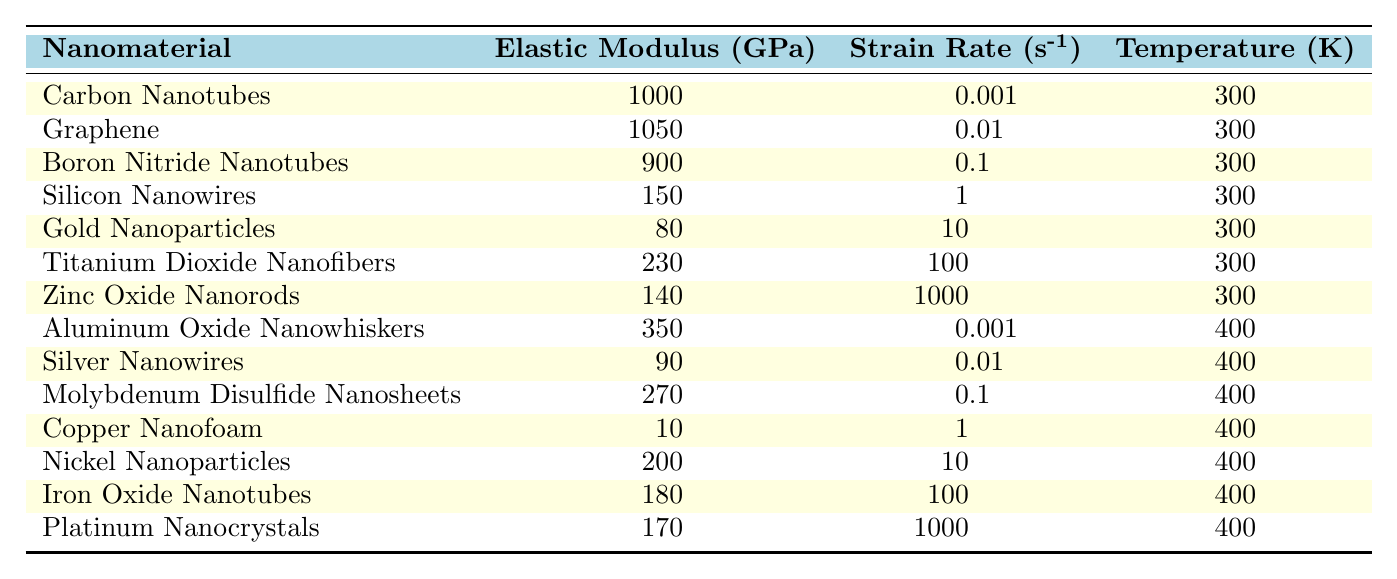What is the elastic modulus of Graphene? The table lists the elastic modulus values for various nanomaterials. For Graphene, the corresponding value is found in the table under the "Elastic Modulus (GPa)" column, which shows 1050 GPa.
Answer: 1050 GPa Which nanomaterial has the lowest elastic modulus? The table presents elastic modulus values for all nanomaterials. Scanning through the "Elastic Modulus (GPa)" column, the value for Copper Nanofoam is the lowest at 10 GPa.
Answer: Copper Nanofoam How many nanomaterials have an elastic modulus greater than 200 GPa? To find this, we should count the number of nanomaterials listed in the table where the elastic modulus value exceeds 200 GPa. These are Carbon Nanotubes, Graphene, Boron Nitride Nanotubes, Titanium Dioxide Nanofibers, Aluminum Oxide Nanowhiskers, and Nickel Nanoparticles, totaling six nanomaterials.
Answer: 6 Is the elastic modulus of Zinc Oxide Nanorods greater than that of Gold Nanoparticles? We look at the elastic modulus values: Zinc Oxide Nanorods has 140 GPa and Gold Nanoparticles has 80 GPa. Since 140 GPa is greater than 80 GPa, the statement is true.
Answer: Yes What is the average elastic modulus of nanomaterials at 300 K? We need to find the elastic modulus values of nanomaterials at 300 K, which are Carbon Nanotubes (1000 GPa), Graphene (1050 GPa), Boron Nitride Nanotubes (900 GPa), Silicon Nanowires (150 GPa), Gold Nanoparticles (80 GPa), Titanium Dioxide Nanofibers (230 GPa), and Zinc Oxide Nanorods (140 GPa). The sum is 1000 + 1050 + 900 + 150 + 80 + 230 + 140 = 3650 GPa. There are 7 nanomaterials, so the average is 3650 / 7 ≈ 521.43 GPa.
Answer: 521.43 GPa Which nanomaterial has the highest elastic modulus at a strain rate of 10 s^-1? We check the data for nanomaterials listed with a strain rate of 10 s^-1. The relevant entries include Gold Nanoparticles (80 GPa) and Nickel Nanoparticles (200 GPa). Among these, Nickel Nanoparticles has the higher elastic modulus.
Answer: Nickel Nanoparticles Is the elastic modulus of aluminum oxide nanowhiskers greater at 400 K than that of silicon nanowires at 300 K? Comparing the values in the table, Aluminum Oxide Nanowhiskers has an elastic modulus of 350 GPa at 400 K and Silicon Nanowires has 150 GPa at 300 K. Since 350 GPa is greater than 150 GPa, the answer is yes.
Answer: Yes What is the total elastic modulus of the three nanomaterials with the highest values? The highest values are from Graphene (1050 GPa), Carbon Nanotubes (1000 GPa), and Boron Nitride Nanotubes (900 GPa). Adding these gives us 1050 + 1000 + 900 = 2950 GPa.
Answer: 2950 GPa 